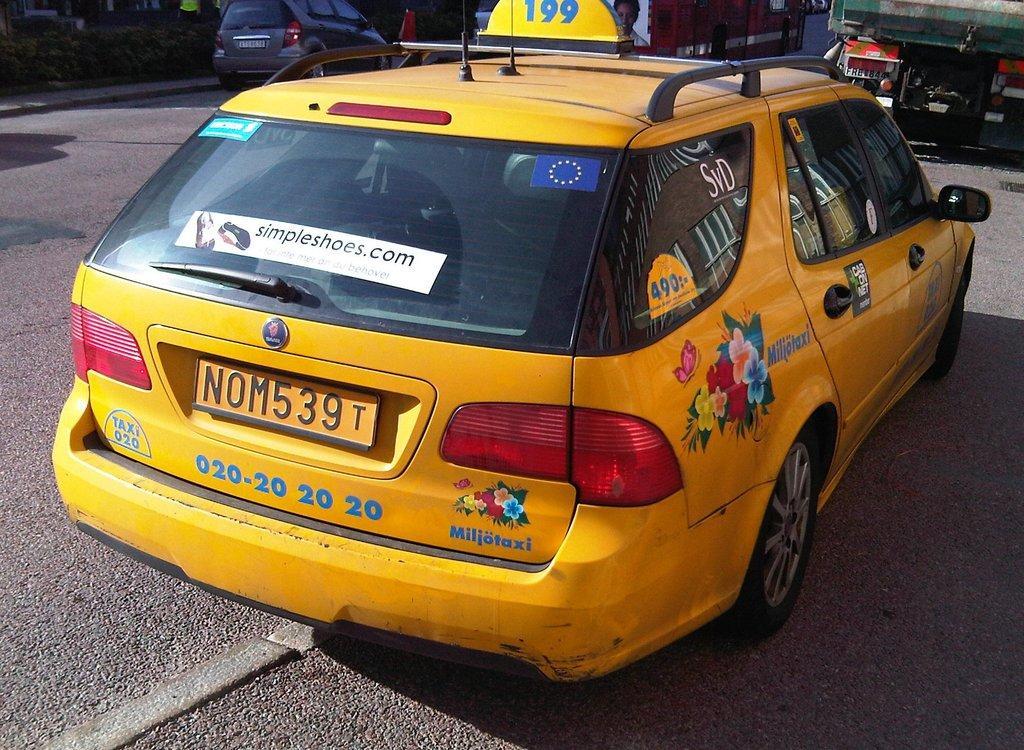Could you give a brief overview of what you see in this image? In this picture we can see few cars on the road, in the background we can find few buildings, at the top of the image we can see few plants and a person. 